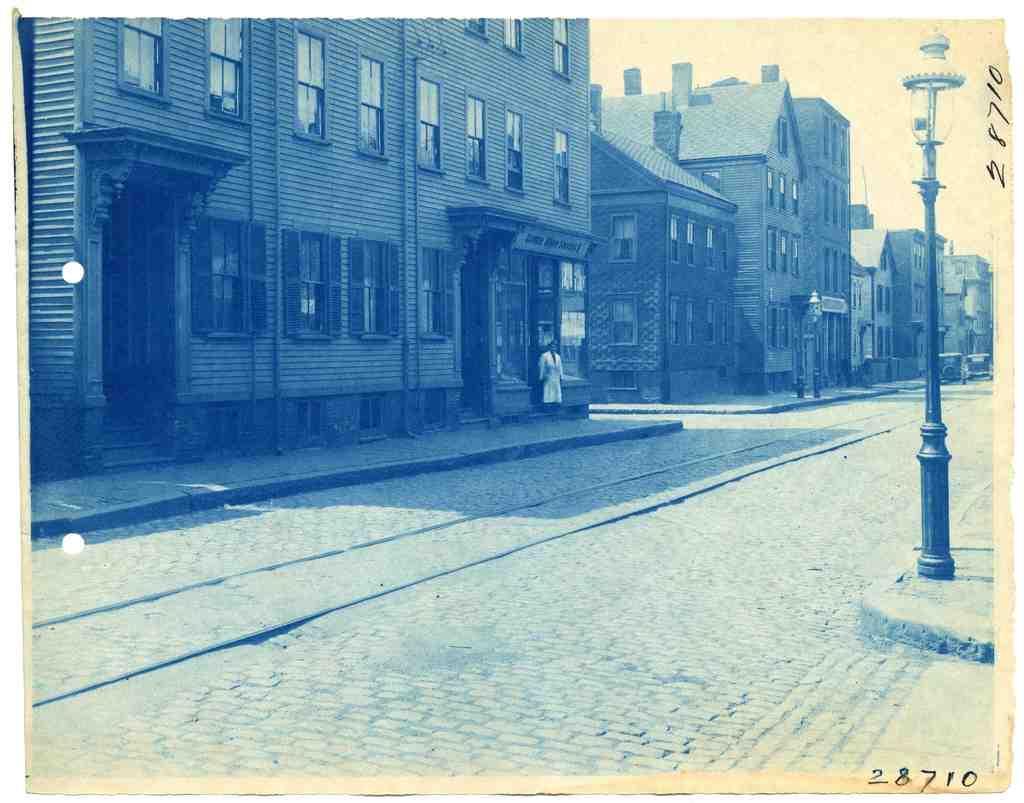In one or two sentences, can you explain what this image depicts? It is the picture in which there is a road in the middle. Beside the road there are buildings. There is a man on the footpath. On the right side there is a light pole on the footpath. At the top there is the sky. It is the black and white image. 